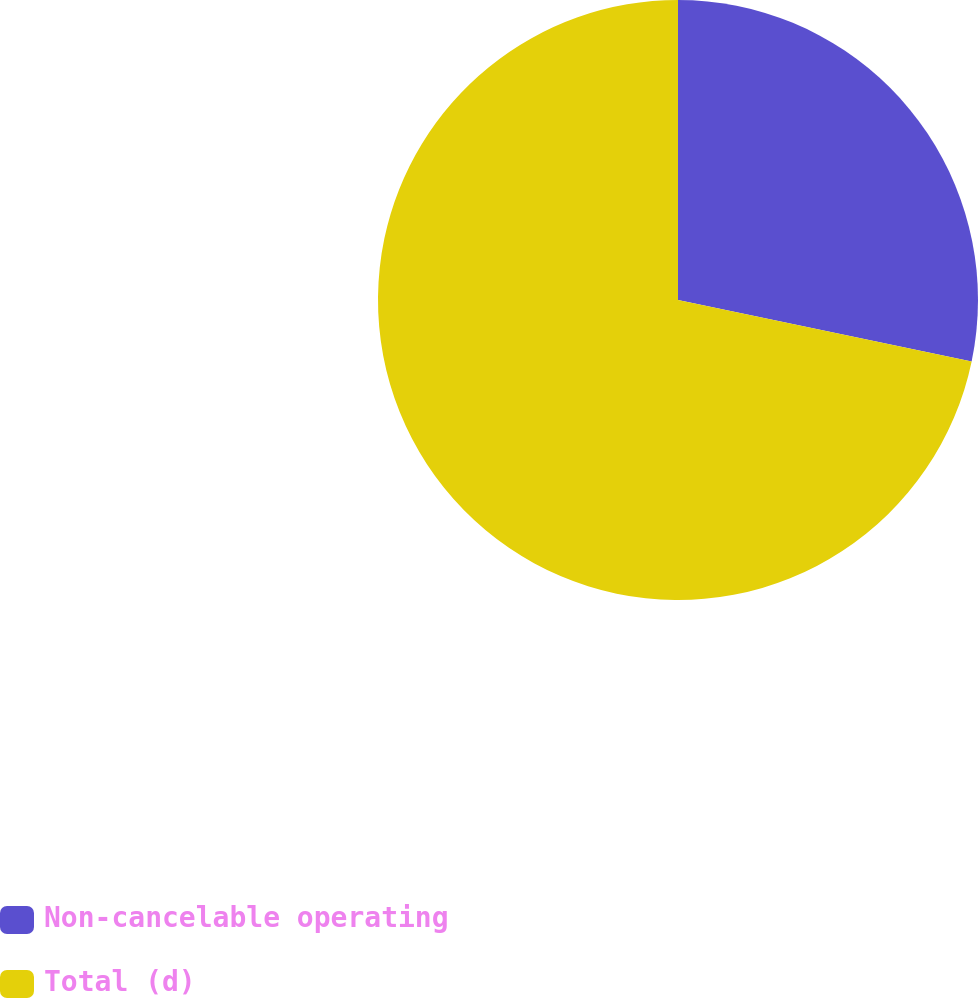<chart> <loc_0><loc_0><loc_500><loc_500><pie_chart><fcel>Non-cancelable operating<fcel>Total (d)<nl><fcel>28.28%<fcel>71.72%<nl></chart> 